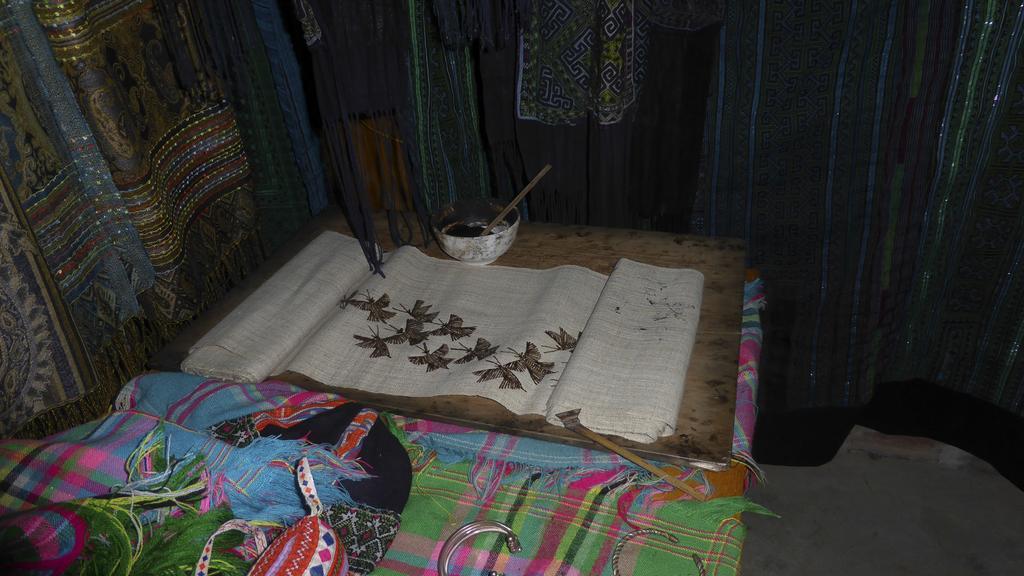How would you summarize this image in a sentence or two? In the background of the picture there are various clothes. In the center of the picture there is a wooden plank, on the plank there is a bowl, cloth and sticks. At the bottom there are clothes and some metal objects. On the right it is floor. 